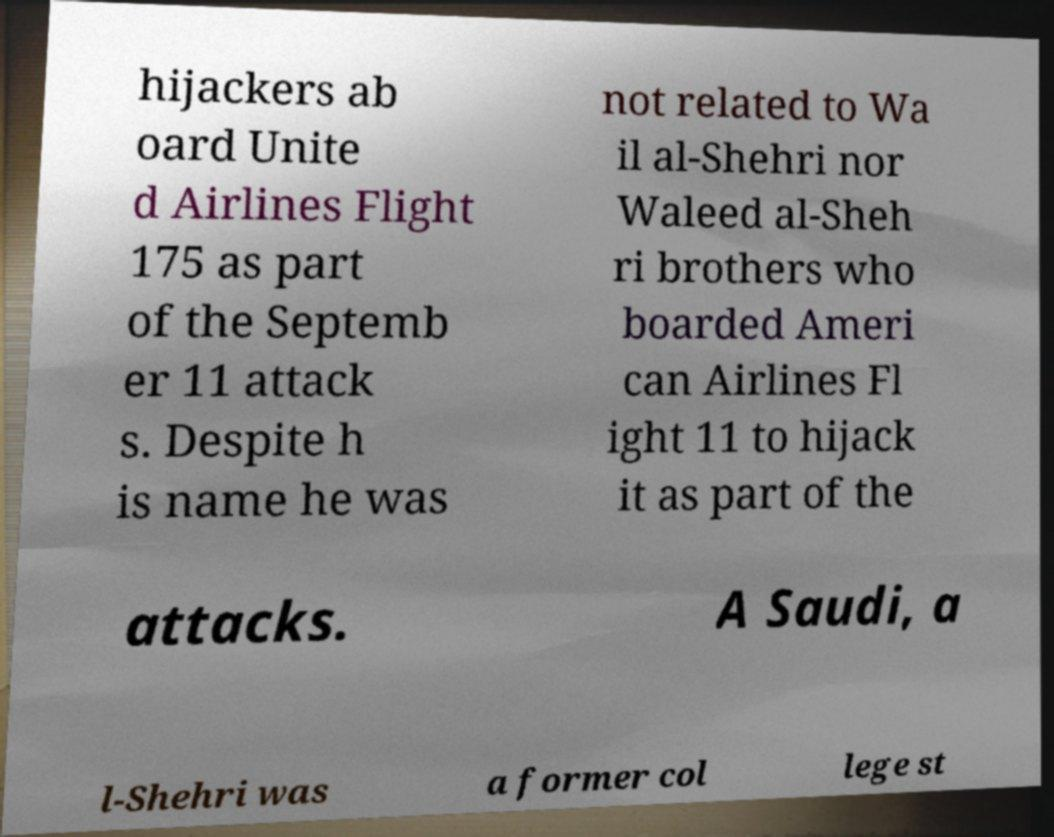Can you read and provide the text displayed in the image?This photo seems to have some interesting text. Can you extract and type it out for me? hijackers ab oard Unite d Airlines Flight 175 as part of the Septemb er 11 attack s. Despite h is name he was not related to Wa il al-Shehri nor Waleed al-Sheh ri brothers who boarded Ameri can Airlines Fl ight 11 to hijack it as part of the attacks. A Saudi, a l-Shehri was a former col lege st 